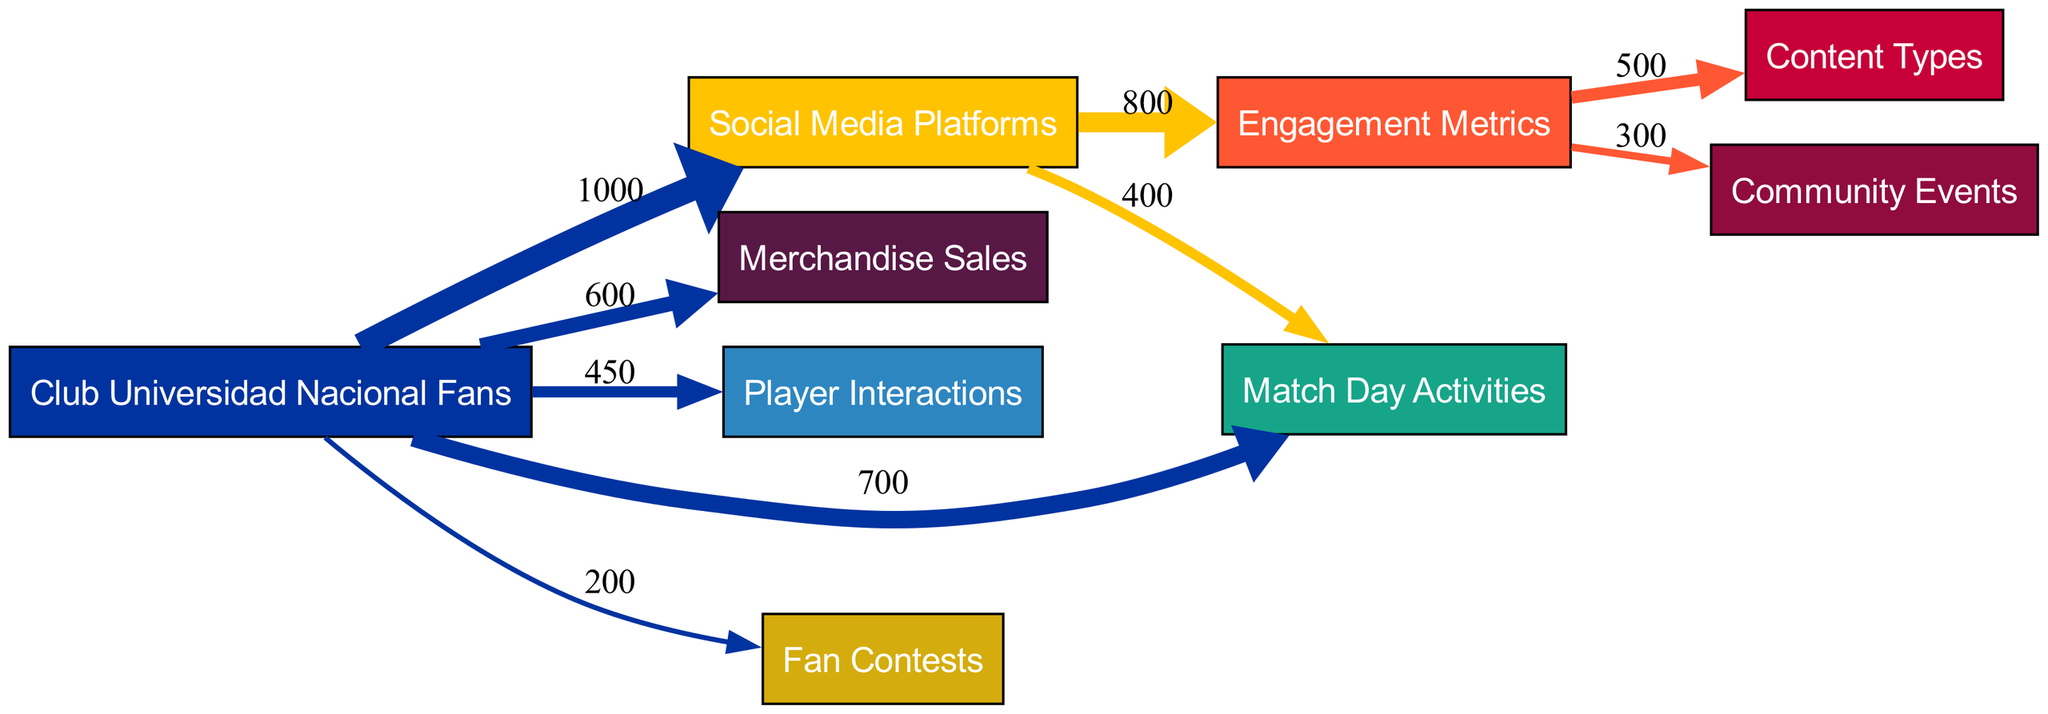What is the total number of nodes in the diagram? The diagram displays nodes for "Club Universidad Nacional Fans," "Social Media Platforms," "Engagement Metrics," "Content Types," "Community Events," "Merchandise Sales," "Player Interactions," "Match Day Activities," and "Fan Contests." Counting these nodes gives a total of 9.
Answer: 9 What is the value of the link from "Social Media Platforms" to "Engagement Metrics"? The diagram shows a direct link from "Social Media Platforms" to "Engagement Metrics" with a value of 800.
Answer: 800 Which engagement metric has the highest flow from "Engagement Metrics"? Among the outgoing flows from "Engagement Metrics," "Content Types" has the maximum flow of 500 compared to 300 for "Community Events."
Answer: Content Types How many fans engage with merchandise sales? The diagram indicates that 600 fans engage with merchandise sales through a direct link from "Club Universidad Nacional Fans."
Answer: 600 What is the total flow from "Club Universidad Nacional Fans" to "Match Day Activities"? The total flow includes 700 fans directly linked from "Club Universidad Nacional Fans" to "Match Day Activities" and 400 fans linked from "Social Media Platforms" to "Match Day Activities," resulting in a total of 1100.
Answer: 1100 Which type of content receives the most engagement from fans? The highest value linking from "Engagement Metrics" is to "Content Types," with a flow of 500, indicating this content type receives the most engagement.
Answer: Content Types How many fans participate in fan contests? The diagram shows that 200 fans interact with fan contests through a link from "Club Universidad Nacional Fans."
Answer: 200 What is the flow value that connects "Social Media Platforms" to "Match Day Activities"? The diagram clearly shows a flow value of 400 fans from "Social Media Platforms" to "Match Day Activities."
Answer: 400 Which community event has more engagement – by value, the flow from "Engagement Metrics" or the flow from "Club Universidad Nacional Fans"? The link to "Community Events" from "Engagement Metrics" is 300, while the flow from "Club Universidad Nacional Fans" does not connect to it directly. Therefore, 300 is the only value to consider.
Answer: 300 